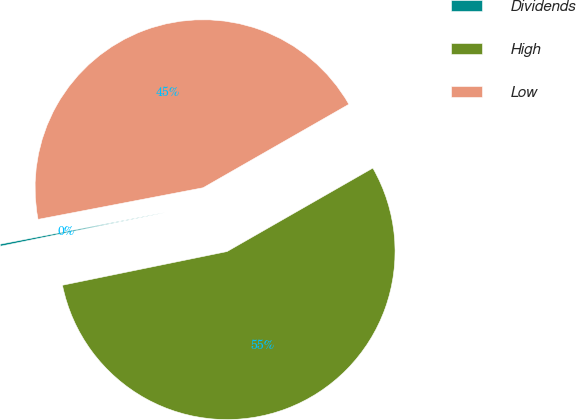<chart> <loc_0><loc_0><loc_500><loc_500><pie_chart><fcel>Dividends<fcel>High<fcel>Low<nl><fcel>0.2%<fcel>55.06%<fcel>44.74%<nl></chart> 